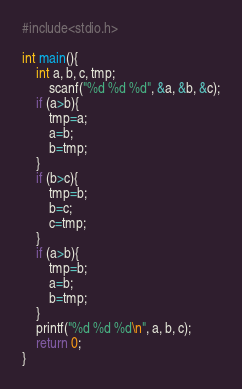<code> <loc_0><loc_0><loc_500><loc_500><_C_>#include<stdio.h>

int main(){
    int a, b, c, tmp;
        scanf("%d %d %d", &a, &b, &c);
    if (a>b){
        tmp=a;
        a=b;
        b=tmp;
    }
    if (b>c){
        tmp=b;
        b=c;
        c=tmp;
    }
    if (a>b){
        tmp=b;
        a=b;
        b=tmp;
    }
    printf("%d %d %d\n", a, b, c);
    return 0;
}</code> 